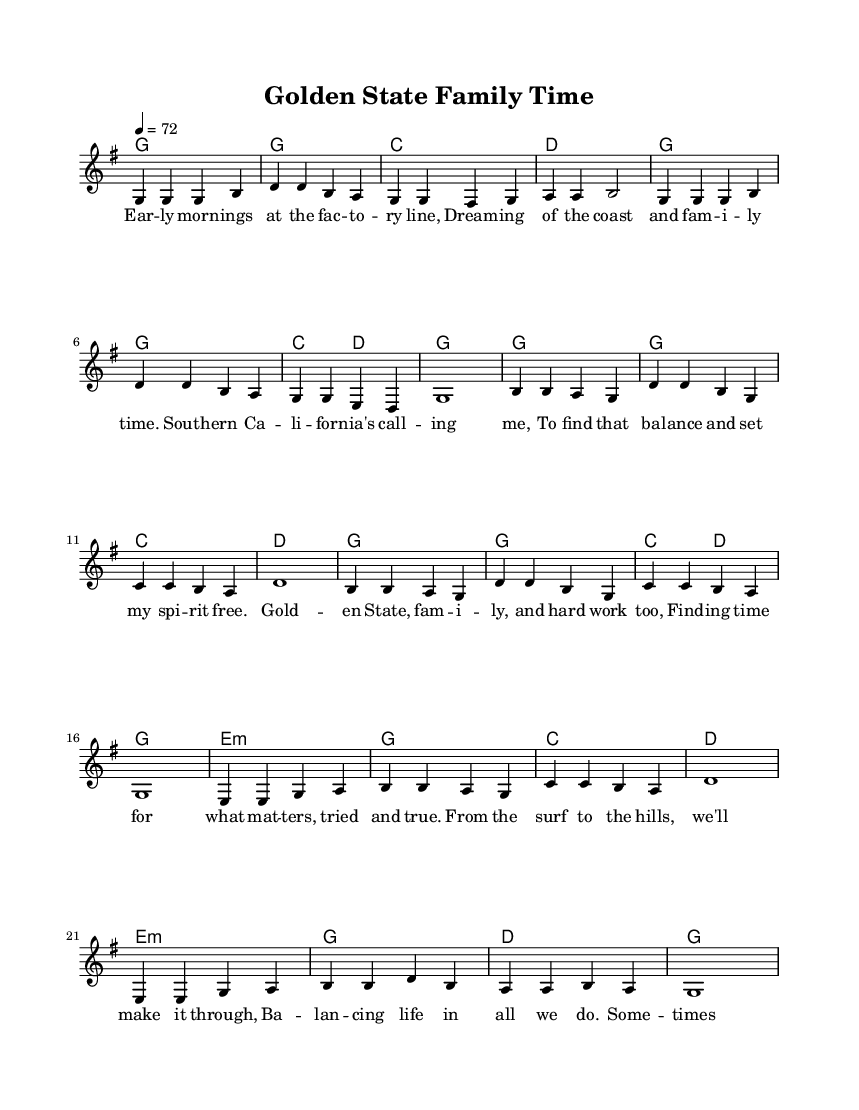What is the key signature of this music? The key signature is indicated at the beginning of the sheet music. It shows one sharp, which corresponds to the key of G major.
Answer: G major What is the time signature of this music? The time signature at the start is written as 4/4, meaning there are four beats in each measure, and each beat is a quarter note.
Answer: 4/4 What is the tempo marking of this music? The tempo marking is found near the top of the sheet music, indicating a speed of quarter note equals 72 beats per minute, which signifies a moderate pace.
Answer: 72 How many verses are in this piece? The sheet music structure reveals that there is one verse followed by a chorus and a bridge, thus indicating one verse is present.
Answer: 1 What is the poetic theme discussed in the lyrics? The lyrics reflect on work-life balance and family values, particularly in Southern California, highlighting the importance of both family and hard work.
Answer: Work-life balance Which chord is played during the bridge section? The bridge section starts with an E minor chord (e1:m), as indicated in the chord definitions, setting a different emotional tone than the verse and chorus.
Answer: E minor How does the chorus reflect the musical style of Country music? The chorus contains themes of family and perseverance, common in Country music, and uses simple, emotive language typical of the genre, emphasizing relatable experiences.
Answer: Family and hard work 